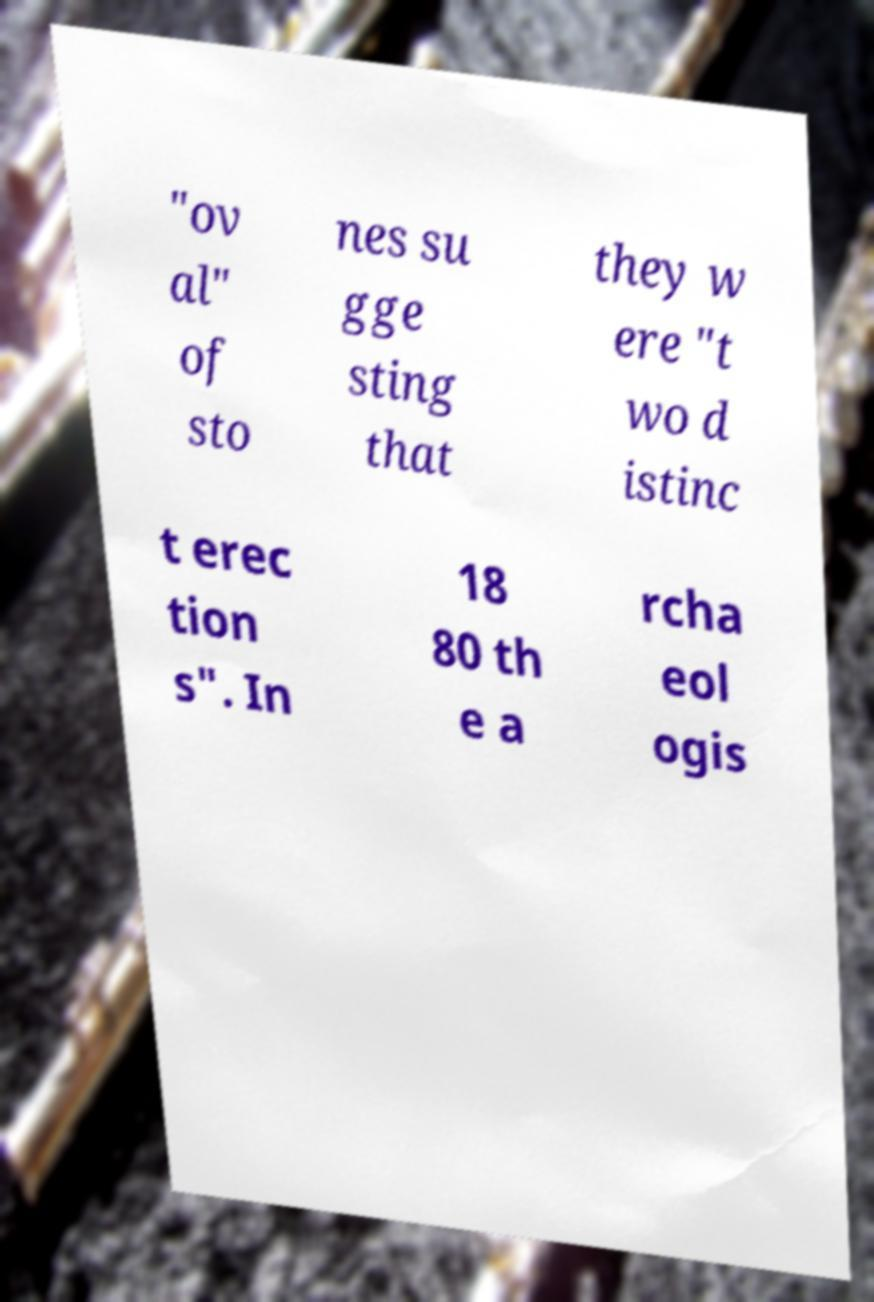Please identify and transcribe the text found in this image. "ov al" of sto nes su gge sting that they w ere "t wo d istinc t erec tion s". In 18 80 th e a rcha eol ogis 